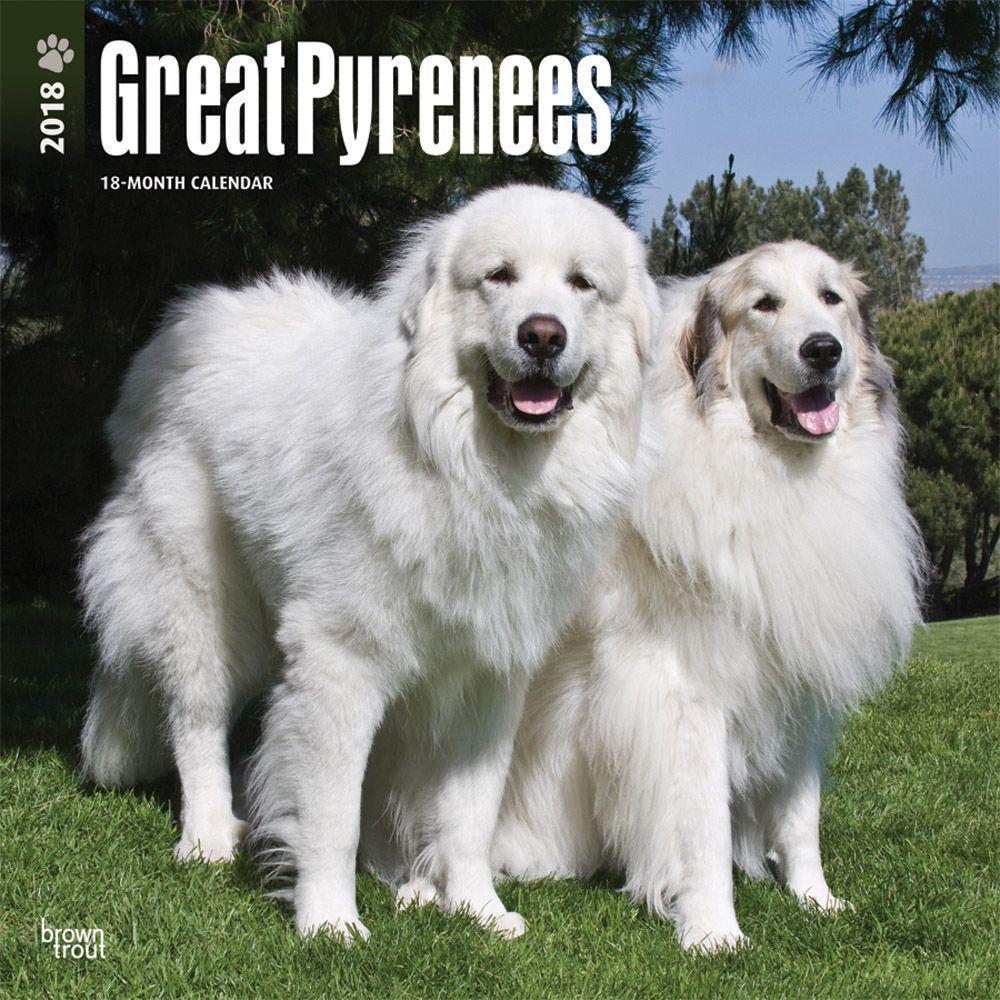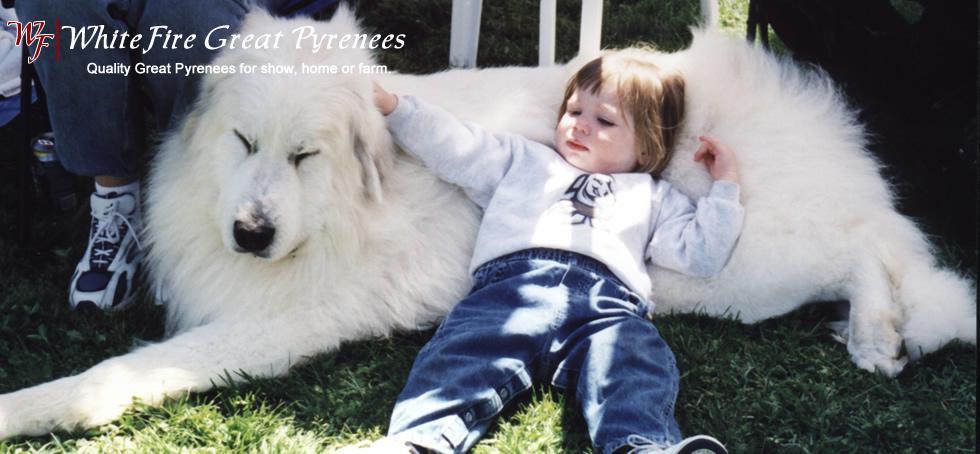The first image is the image on the left, the second image is the image on the right. Examine the images to the left and right. Is the description "The left image contains one non-standing white puppy, while the right image contains one standing white adult dog." accurate? Answer yes or no. No. The first image is the image on the left, the second image is the image on the right. For the images shown, is this caption "There is one puppy and one adult dog" true? Answer yes or no. No. 